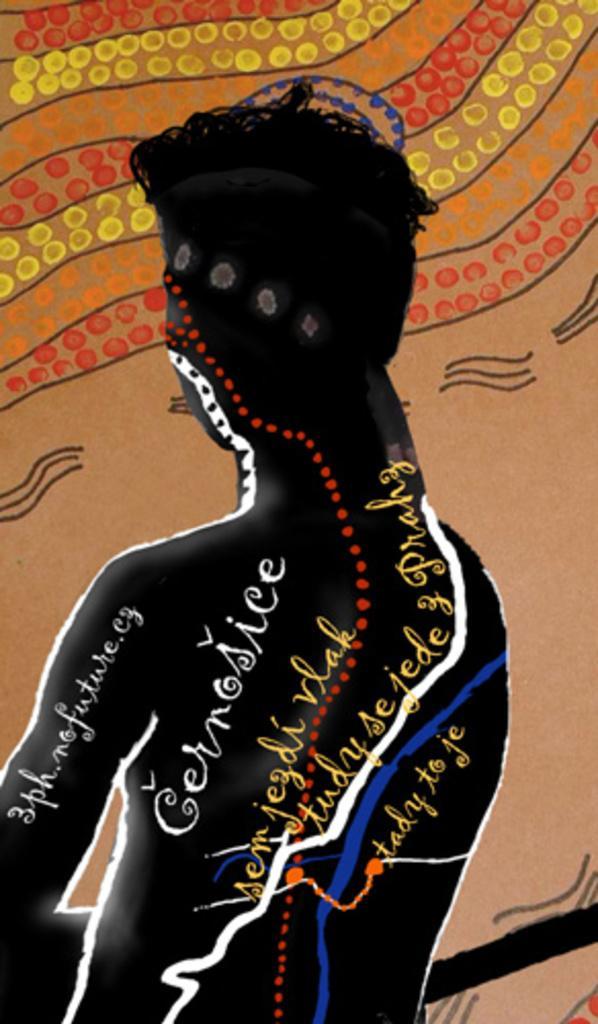Could you give a brief overview of what you see in this image? In this picture we can see painting, person and some text. 